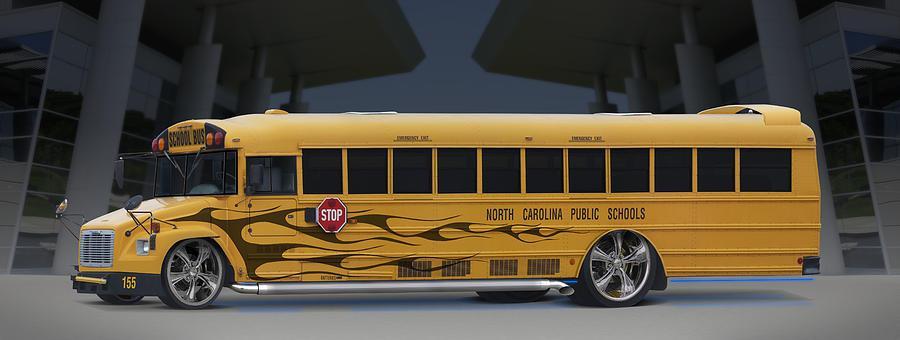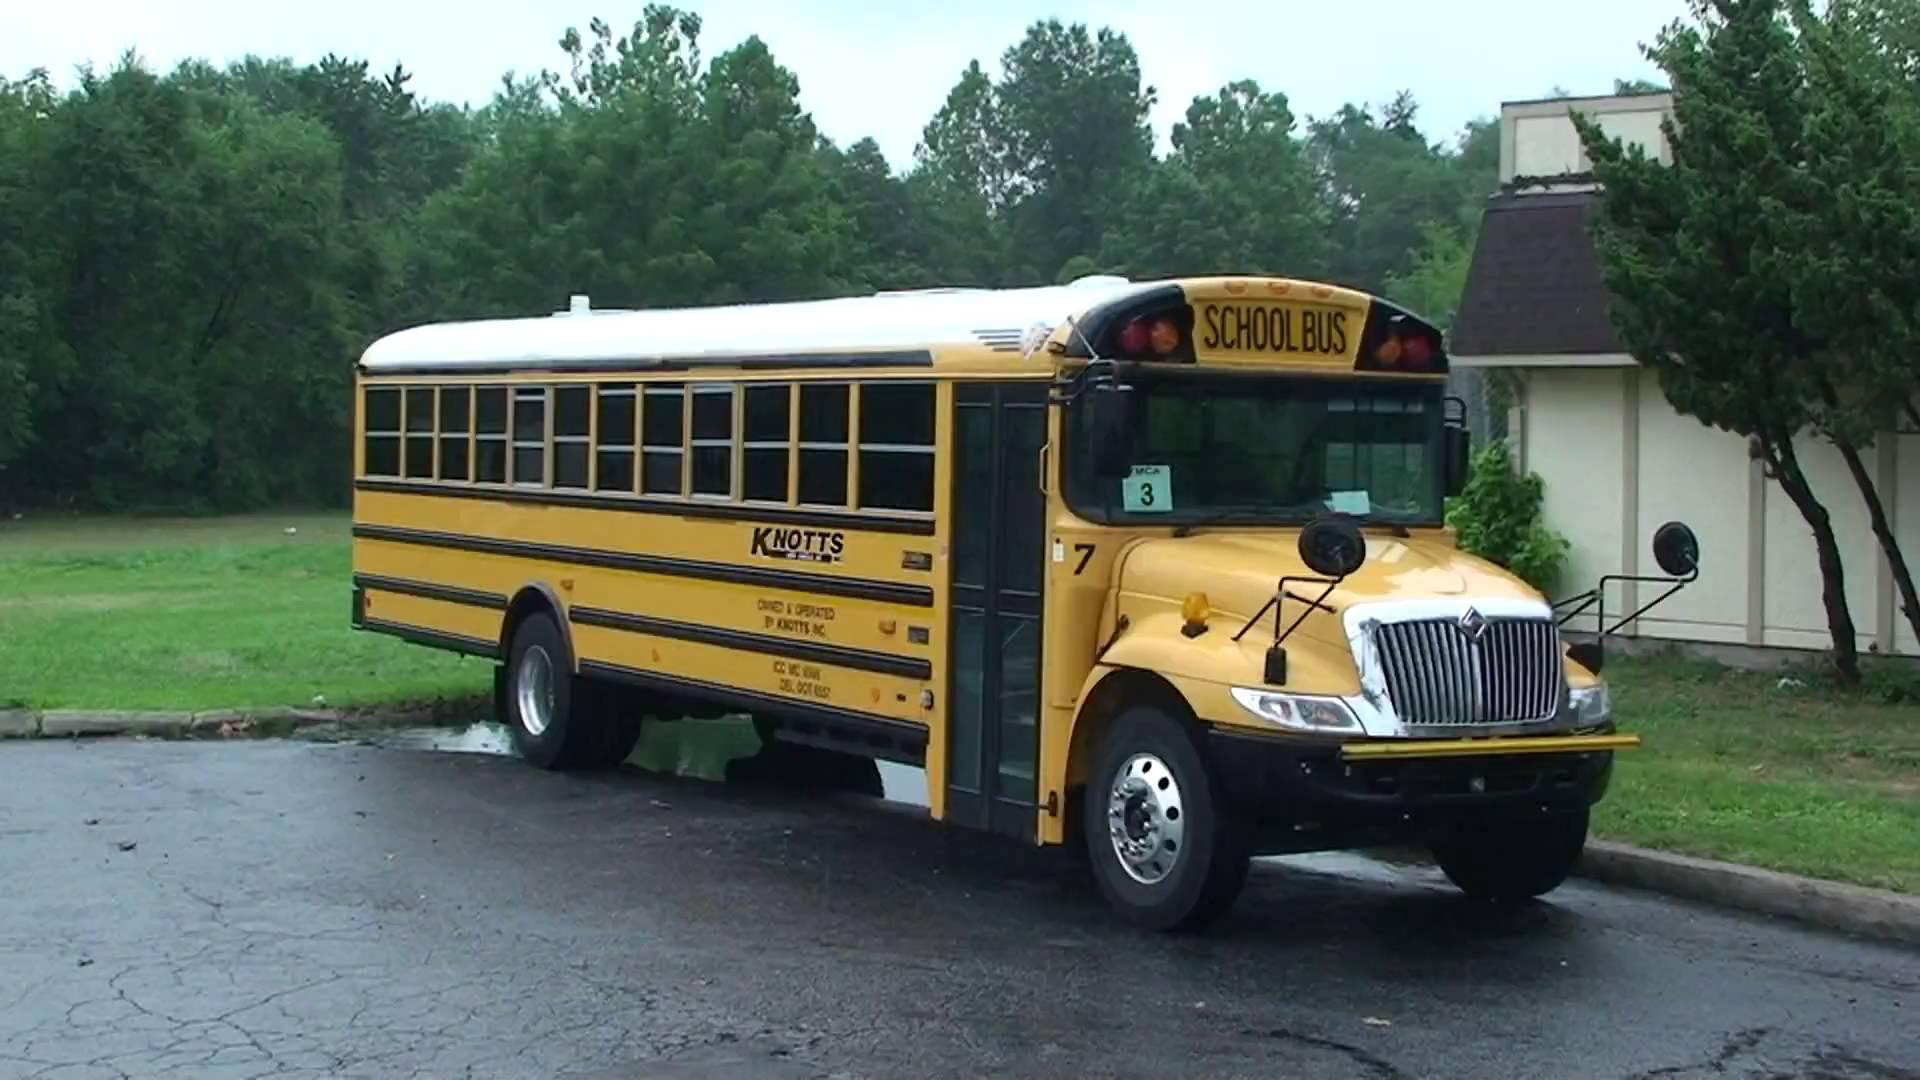The first image is the image on the left, the second image is the image on the right. Examine the images to the left and right. Is the description "A bus' left side is visible." accurate? Answer yes or no. Yes. The first image is the image on the left, the second image is the image on the right. Examine the images to the left and right. Is the description "The combined images show two buses heading in the same direction with a shorter bus appearing to be leading." accurate? Answer yes or no. No. 